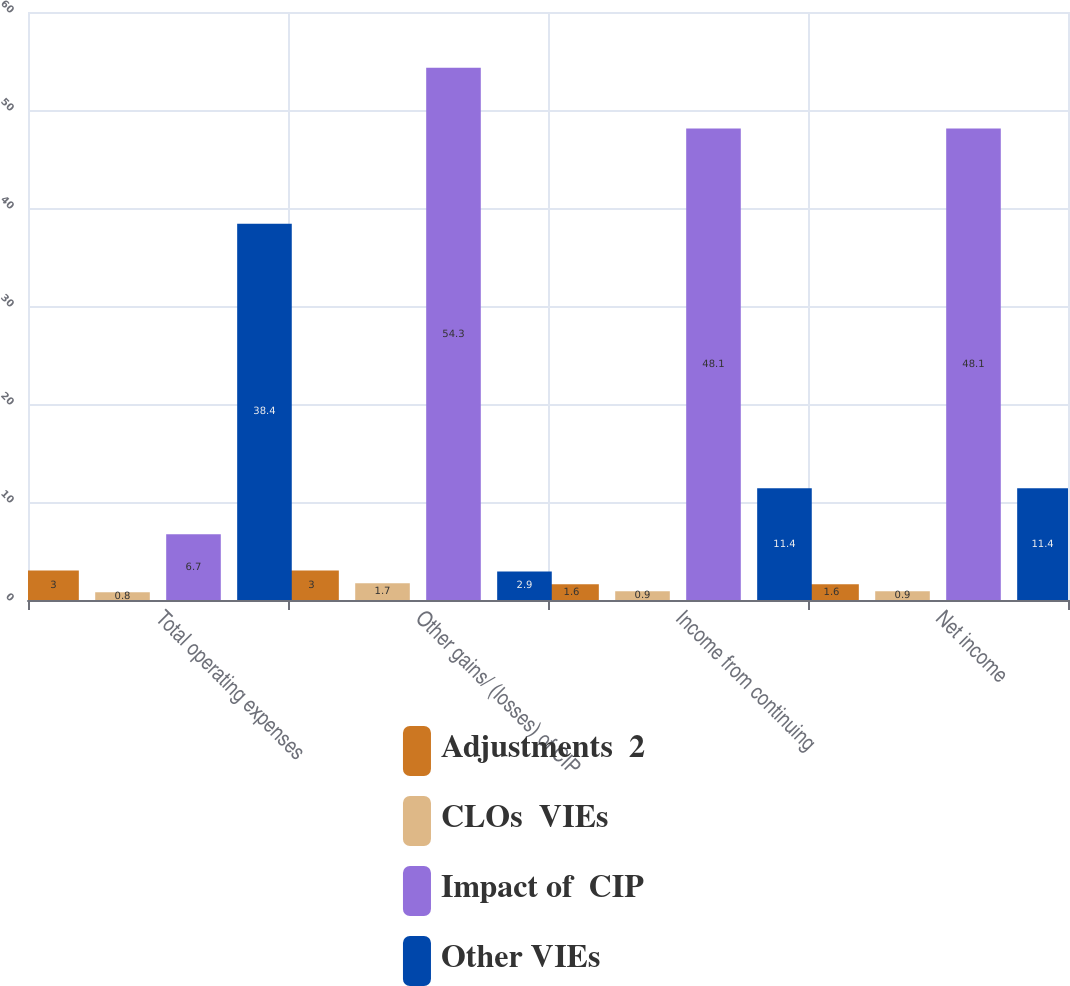Convert chart. <chart><loc_0><loc_0><loc_500><loc_500><stacked_bar_chart><ecel><fcel>Total operating expenses<fcel>Other gains/ (losses) of CIP<fcel>Income from continuing<fcel>Net income<nl><fcel>Adjustments  2<fcel>3<fcel>3<fcel>1.6<fcel>1.6<nl><fcel>CLOs  VIEs<fcel>0.8<fcel>1.7<fcel>0.9<fcel>0.9<nl><fcel>Impact of  CIP<fcel>6.7<fcel>54.3<fcel>48.1<fcel>48.1<nl><fcel>Other VIEs<fcel>38.4<fcel>2.9<fcel>11.4<fcel>11.4<nl></chart> 